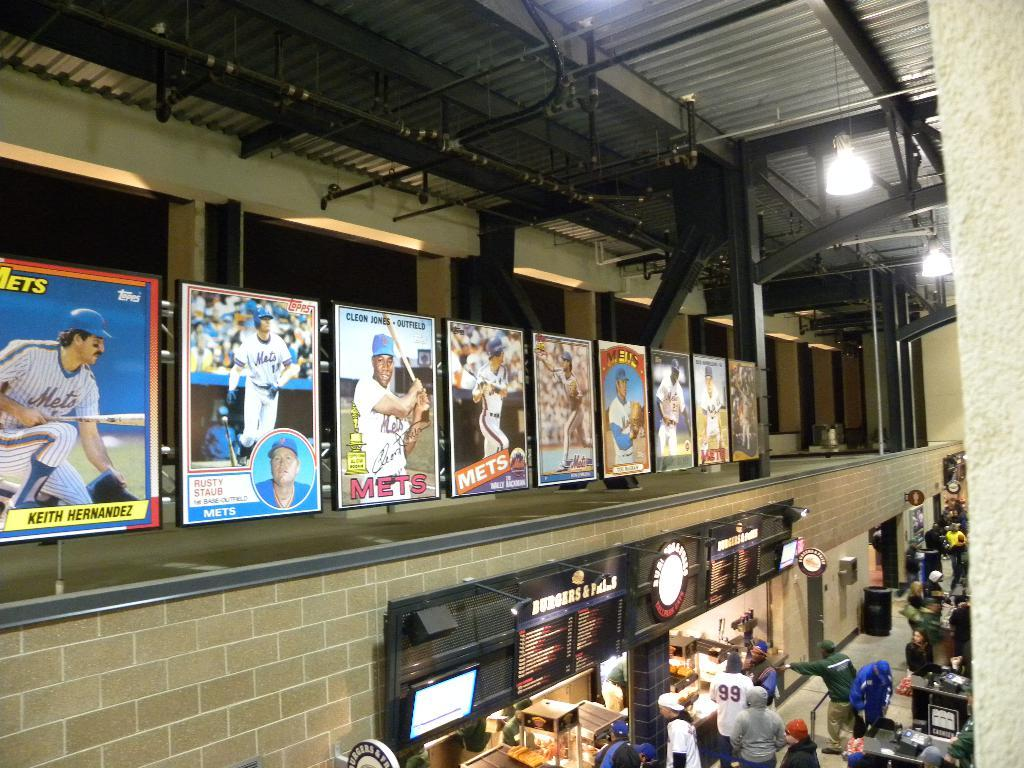<image>
Render a clear and concise summary of the photo. Sports Stadium with people in line for food under the Burgers sign. 